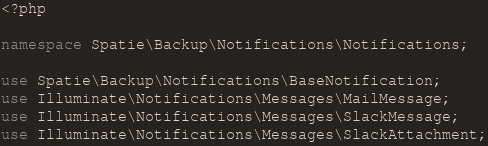Convert code to text. <code><loc_0><loc_0><loc_500><loc_500><_PHP_><?php

namespace Spatie\Backup\Notifications\Notifications;

use Spatie\Backup\Notifications\BaseNotification;
use Illuminate\Notifications\Messages\MailMessage;
use Illuminate\Notifications\Messages\SlackMessage;
use Illuminate\Notifications\Messages\SlackAttachment;</code> 